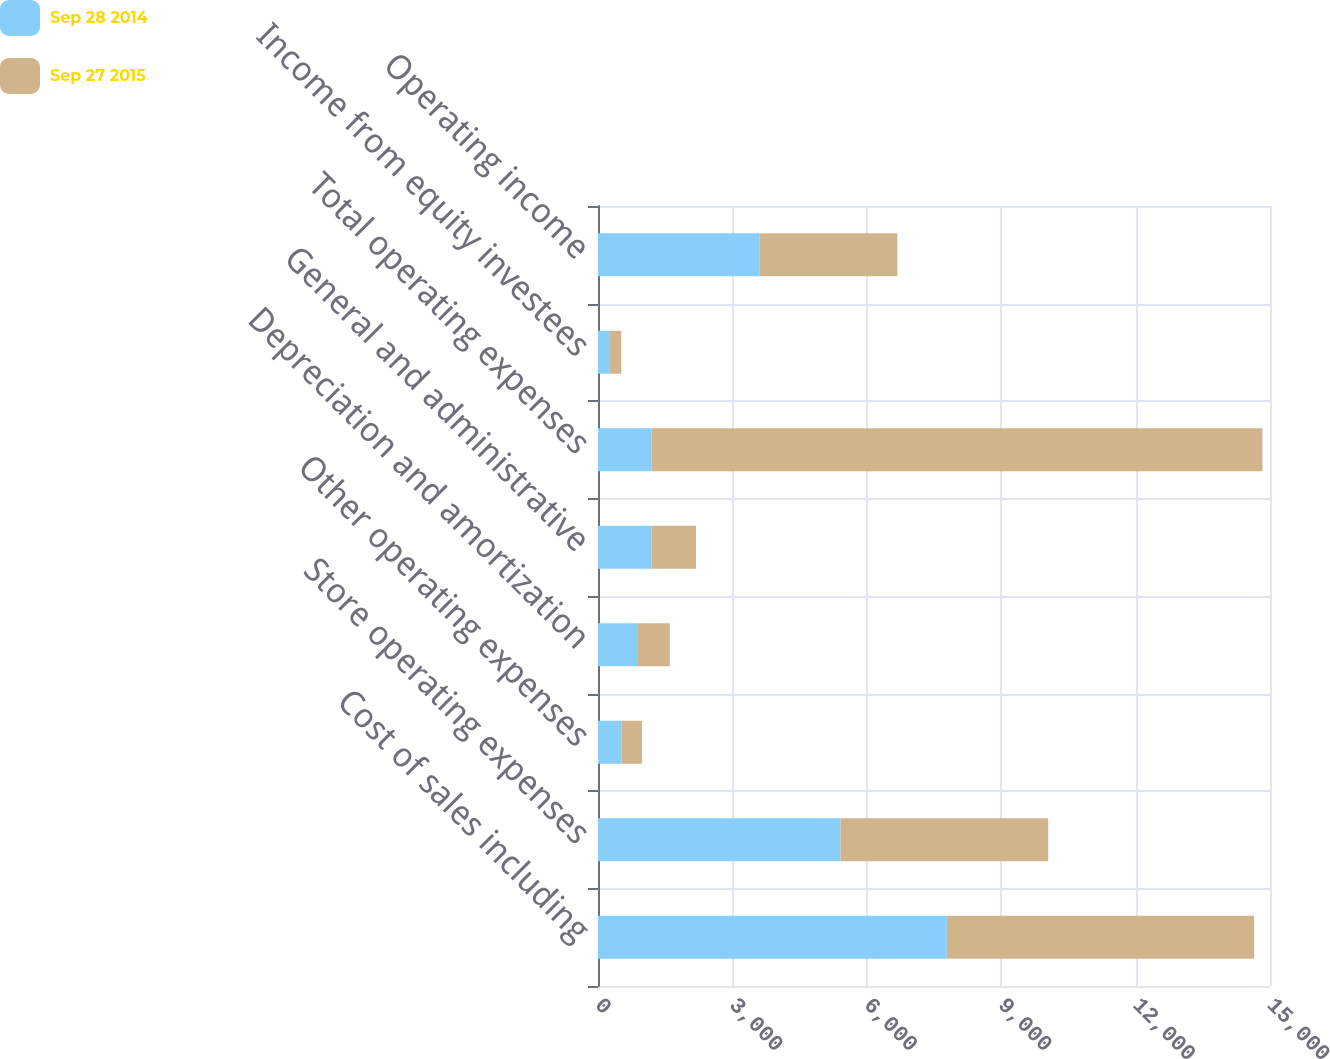<chart> <loc_0><loc_0><loc_500><loc_500><stacked_bar_chart><ecel><fcel>Cost of sales including<fcel>Store operating expenses<fcel>Other operating expenses<fcel>Depreciation and amortization<fcel>General and administrative<fcel>Total operating expenses<fcel>Income from equity investees<fcel>Operating income<nl><fcel>Sep 28 2014<fcel>7787.5<fcel>5411.1<fcel>522.4<fcel>893.9<fcel>1196.7<fcel>1196.7<fcel>249.9<fcel>3601<nl><fcel>Sep 27 2015<fcel>6858.8<fcel>4638.2<fcel>457.3<fcel>709.6<fcel>991.3<fcel>13635<fcel>268.3<fcel>3081.1<nl></chart> 